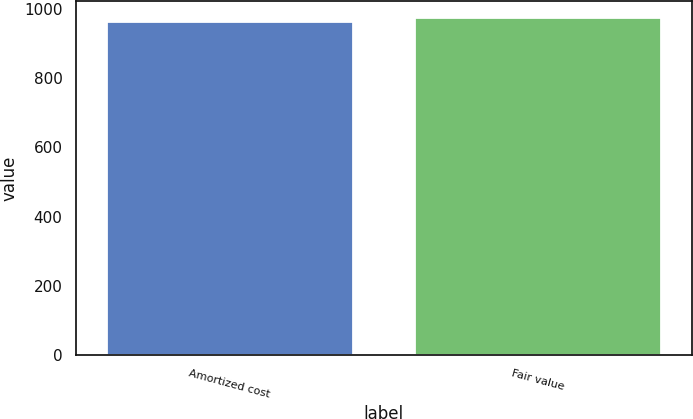Convert chart to OTSL. <chart><loc_0><loc_0><loc_500><loc_500><bar_chart><fcel>Amortized cost<fcel>Fair value<nl><fcel>965<fcel>975<nl></chart> 